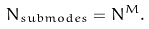Convert formula to latex. <formula><loc_0><loc_0><loc_500><loc_500>N _ { s u b m o d e s } = N ^ { M } .</formula> 